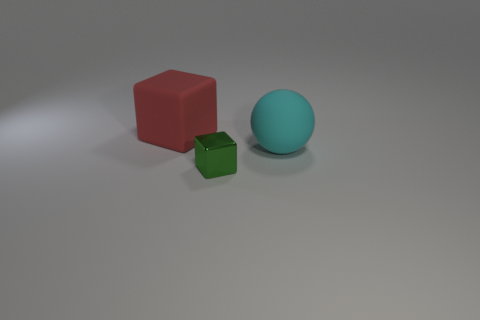Is there anything else that is made of the same material as the tiny block?
Give a very brief answer. No. There is a rubber object that is the same size as the red rubber block; what is its color?
Provide a short and direct response. Cyan. What number of other things are the same shape as the tiny thing?
Keep it short and to the point. 1. Are there any green blocks made of the same material as the small thing?
Offer a very short reply. No. Are the big thing left of the cyan rubber sphere and the big object on the right side of the big block made of the same material?
Your answer should be very brief. Yes. What number of tiny red metal objects are there?
Provide a short and direct response. 0. What shape is the large object that is in front of the red cube?
Ensure brevity in your answer.  Sphere. What number of other objects are there of the same size as the red cube?
Make the answer very short. 1. There is a matte object left of the metal block; is it the same shape as the object that is in front of the big rubber ball?
Provide a short and direct response. Yes. How many cyan rubber balls are in front of the red block?
Provide a succinct answer. 1. 